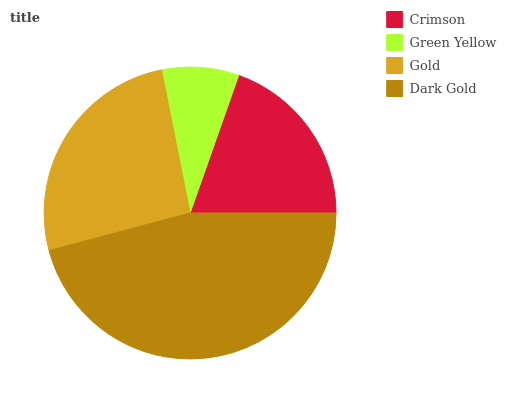Is Green Yellow the minimum?
Answer yes or no. Yes. Is Dark Gold the maximum?
Answer yes or no. Yes. Is Gold the minimum?
Answer yes or no. No. Is Gold the maximum?
Answer yes or no. No. Is Gold greater than Green Yellow?
Answer yes or no. Yes. Is Green Yellow less than Gold?
Answer yes or no. Yes. Is Green Yellow greater than Gold?
Answer yes or no. No. Is Gold less than Green Yellow?
Answer yes or no. No. Is Gold the high median?
Answer yes or no. Yes. Is Crimson the low median?
Answer yes or no. Yes. Is Dark Gold the high median?
Answer yes or no. No. Is Green Yellow the low median?
Answer yes or no. No. 